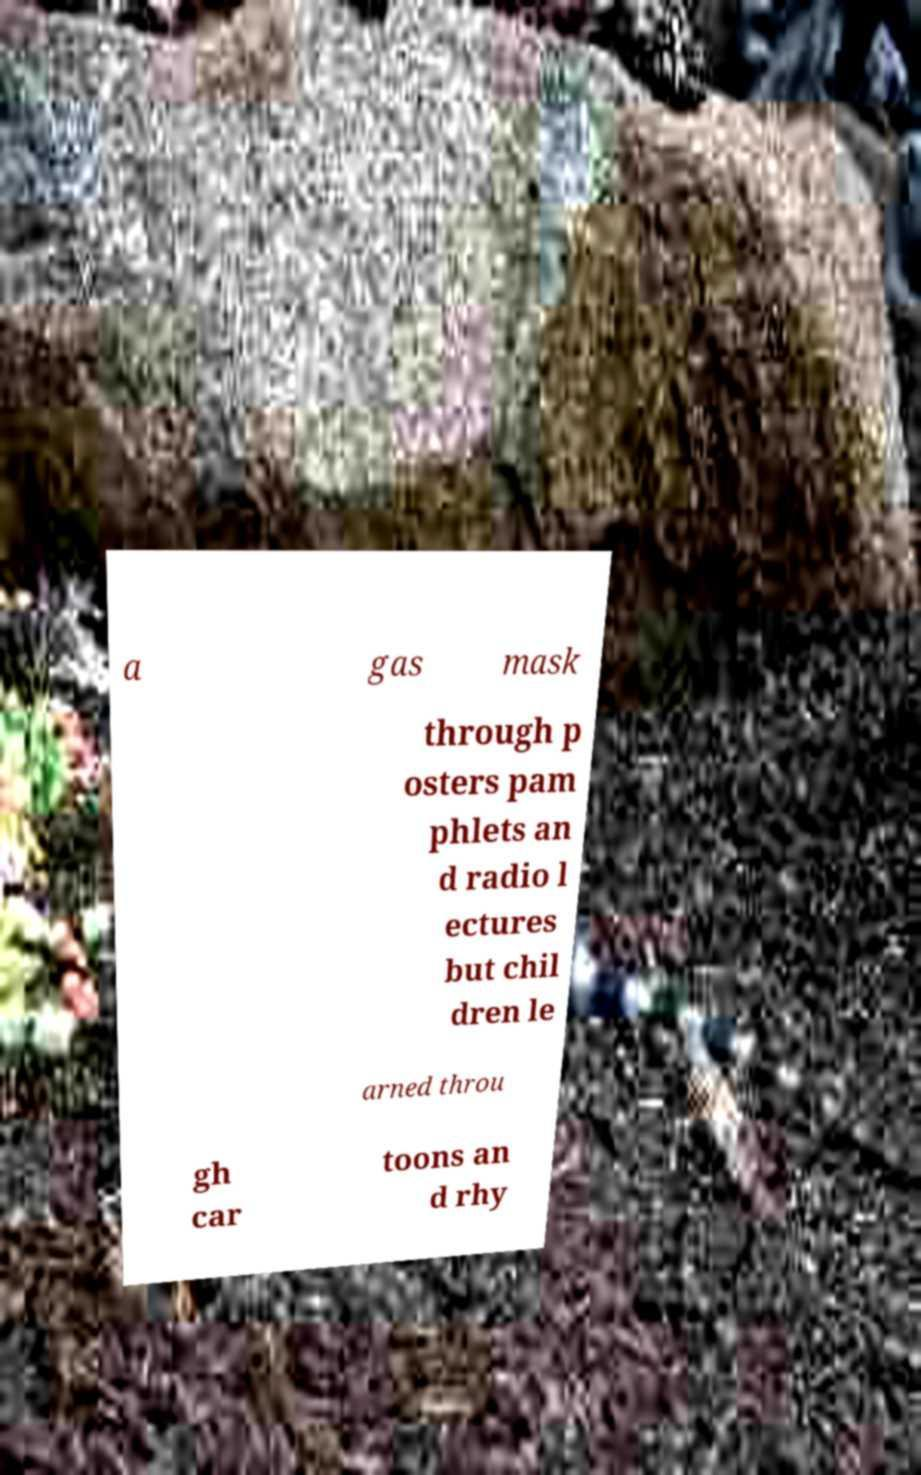Could you extract and type out the text from this image? a gas mask through p osters pam phlets an d radio l ectures but chil dren le arned throu gh car toons an d rhy 